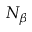Convert formula to latex. <formula><loc_0><loc_0><loc_500><loc_500>N _ { \beta }</formula> 